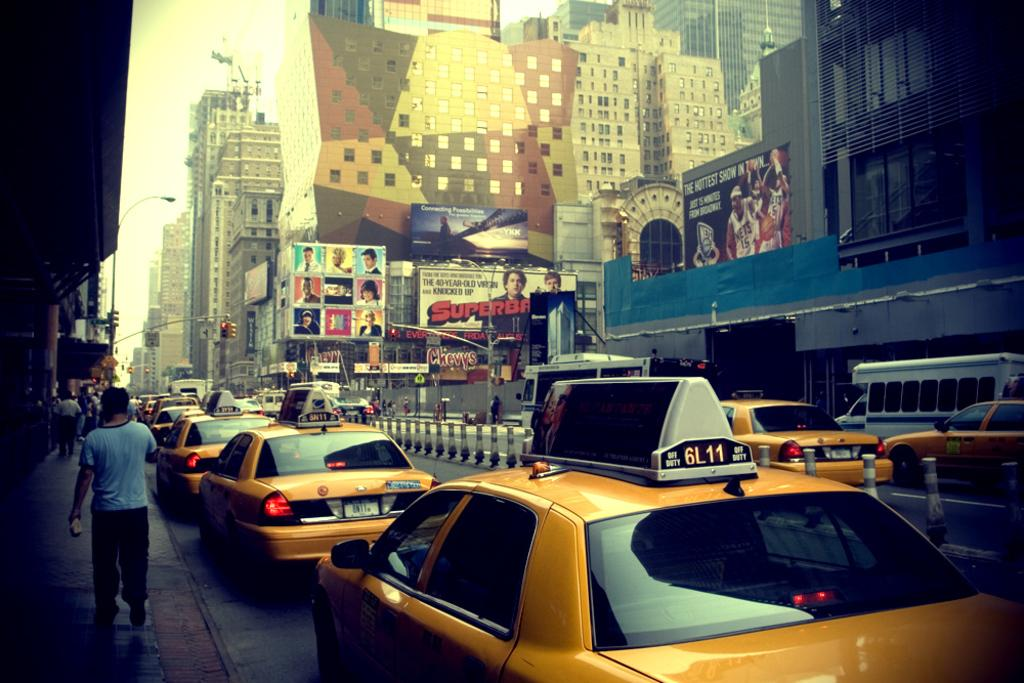<image>
Summarize the visual content of the image. a few cars with one that has the number 6L11 on it 